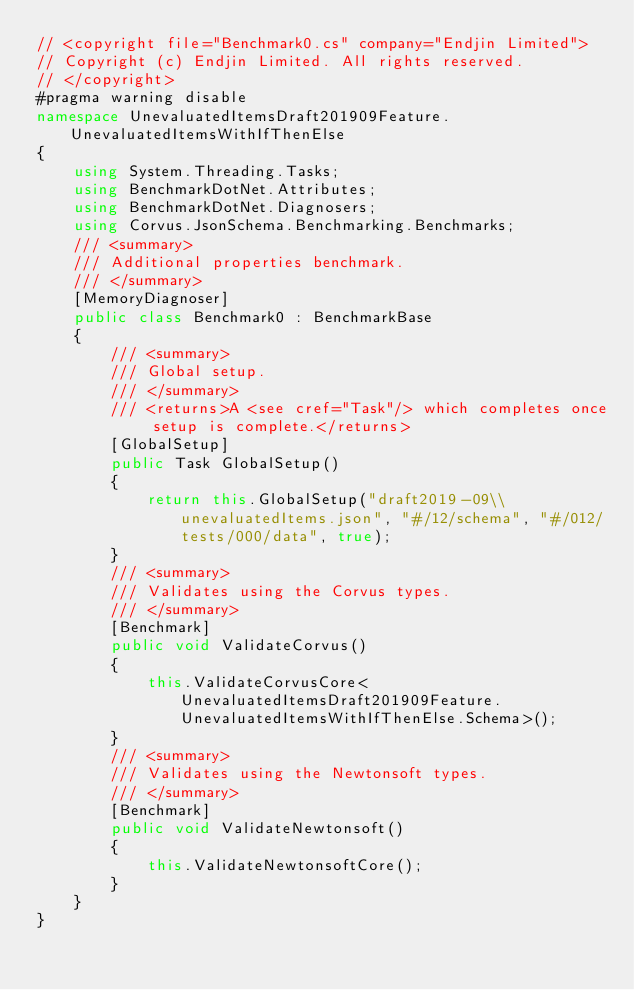<code> <loc_0><loc_0><loc_500><loc_500><_C#_>// <copyright file="Benchmark0.cs" company="Endjin Limited">
// Copyright (c) Endjin Limited. All rights reserved.
// </copyright>
#pragma warning disable
namespace UnevaluatedItemsDraft201909Feature.UnevaluatedItemsWithIfThenElse
{
    using System.Threading.Tasks;
    using BenchmarkDotNet.Attributes;
    using BenchmarkDotNet.Diagnosers;
    using Corvus.JsonSchema.Benchmarking.Benchmarks;
    /// <summary>
    /// Additional properties benchmark.
    /// </summary>
    [MemoryDiagnoser]
    public class Benchmark0 : BenchmarkBase
    {
        /// <summary>
        /// Global setup.
        /// </summary>
        /// <returns>A <see cref="Task"/> which completes once setup is complete.</returns>
        [GlobalSetup]
        public Task GlobalSetup()
        {
            return this.GlobalSetup("draft2019-09\\unevaluatedItems.json", "#/12/schema", "#/012/tests/000/data", true);
        }
        /// <summary>
        /// Validates using the Corvus types.
        /// </summary>
        [Benchmark]
        public void ValidateCorvus()
        {
            this.ValidateCorvusCore<UnevaluatedItemsDraft201909Feature.UnevaluatedItemsWithIfThenElse.Schema>();
        }
        /// <summary>
        /// Validates using the Newtonsoft types.
        /// </summary>
        [Benchmark]
        public void ValidateNewtonsoft()
        {
            this.ValidateNewtonsoftCore();
        }
    }
}
</code> 